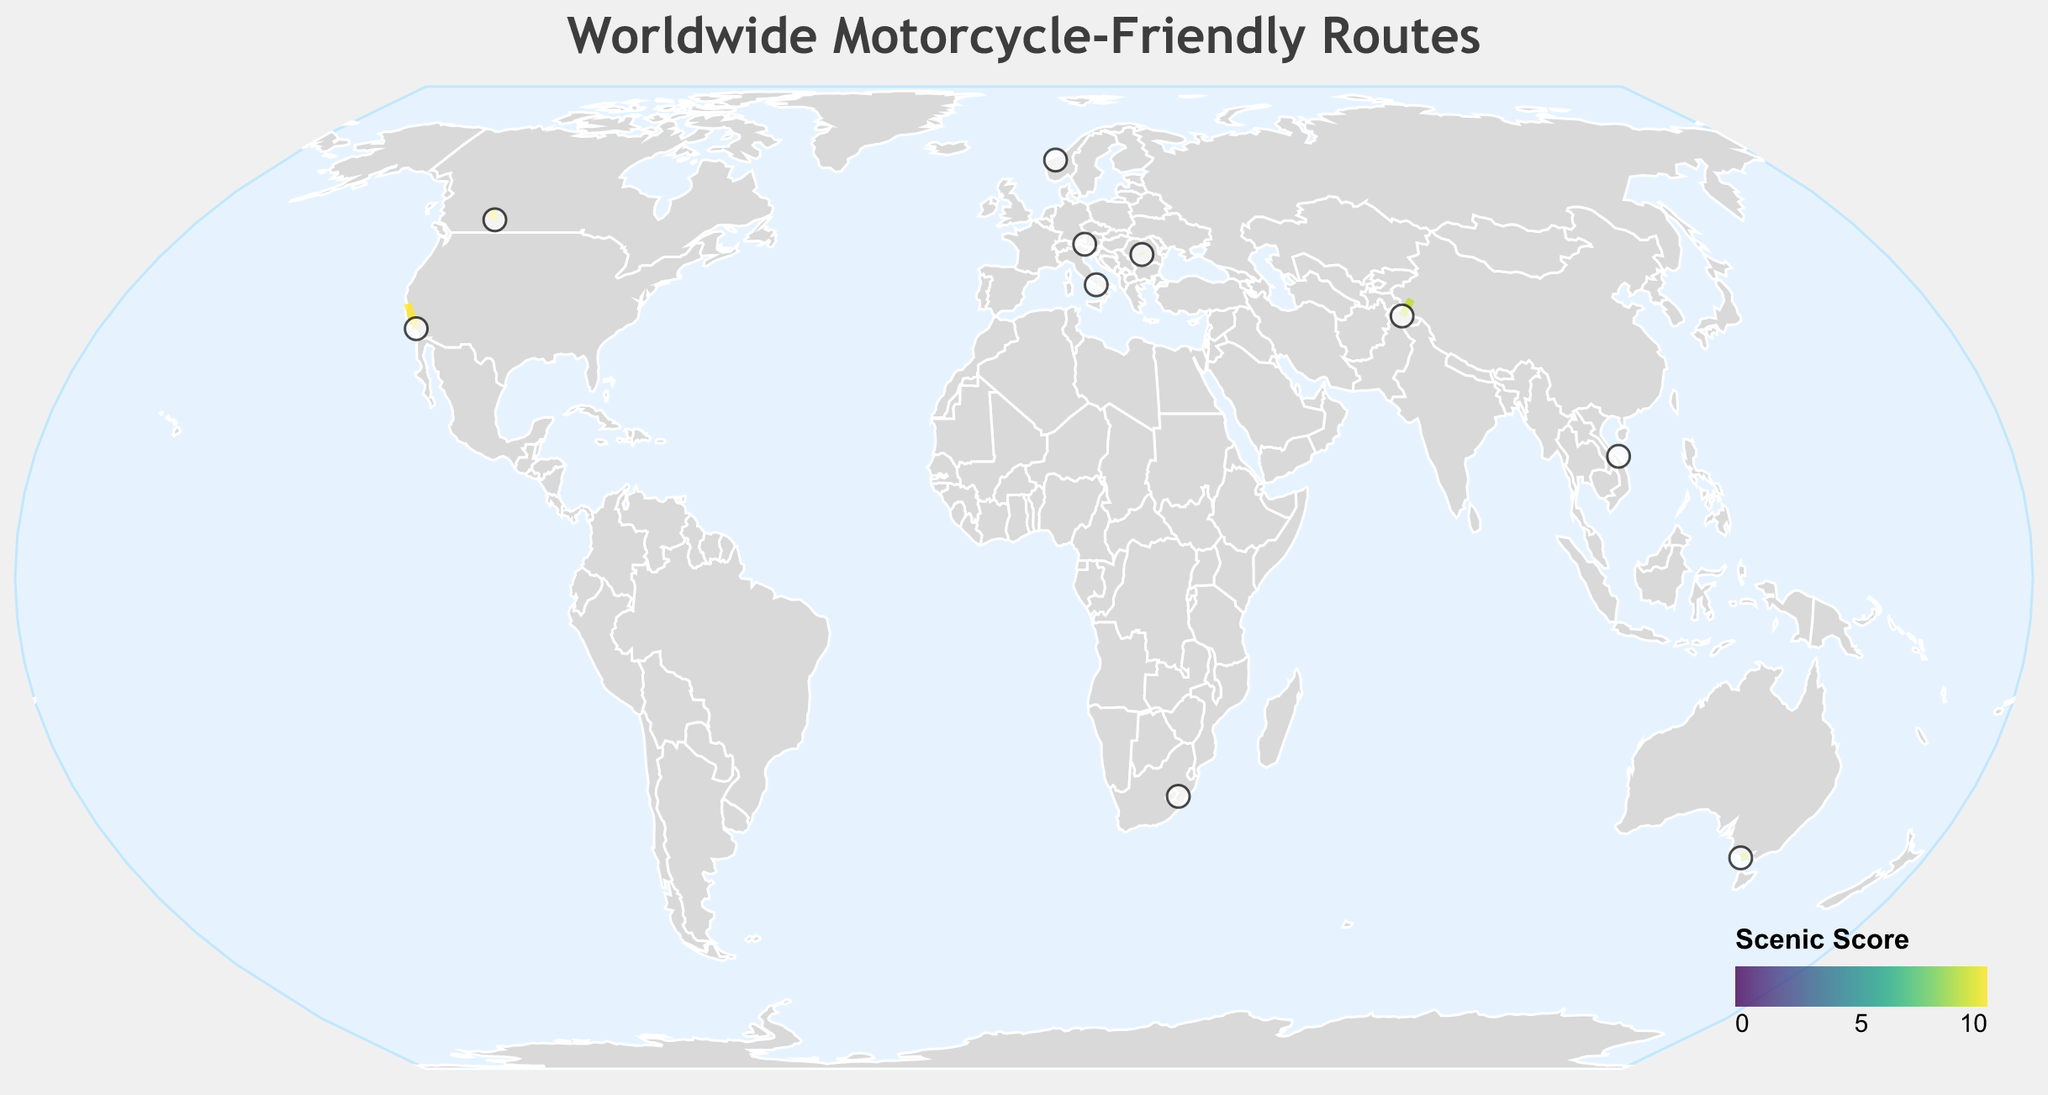What's the title of the figure? The title is usually located at the top of the figure.
Answer: Worldwide Motorcycle-Friendly Routes How many routes have the highest scenic score of 10? By checking the colors that correspond to a scenic score of 10 and matching those routes, we find three routes: Pacific Coast Highway, Trollstigen, Icefields Parkway, and Grossglockner High Alpine Road.
Answer: 4 Which route has the highest difficulty but a scenic score of less than 10? Check for the highest difficulty value that is less than 10 and look for its corresponding scenic score. The Sani Pass in Lesotho has a difficulty of 9 and a scenic score of 8.
Answer: Sani Pass Which continent has the most routes listed? By visually identifying the continents and counting the number of routes, it appears that Europe has the most routes listed (Romania, Norway, Italy, Austria).
Answer: Europe What's the average difficulty rating of all routes? Add up all difficulty ratings and divide by the number of routes: (7 + 4 + 3 + 8 + 6 + 5 + 7 + 9 + 8 + 6) / 10 = 63 / 10 = 6.3
Answer: 6.3 Which country has a route with the highest scenic score? Locate the country associated with any route that has a scenic score of 10. The routes are the Pacific Coast Highway (USA), Trollstigen (Norway), Icefields Parkway (Canada), and Grossglockner High Alpine Road (Austria).
Answer: USA, Norway, Canada, Austria Compare the difficulty levels of Trollstigen in Norway and the Great Ocean Road in Australia. Which is harder? Trollstigen has a difficulty level of 8, while the Great Ocean Road has a difficulty level of 3.
Answer: Trollstigen Are there any routes with the same start and end coordinates? By examining the coordinates, it appears there are no routes with identical start and end coordinates.
Answer: No Which route has the smallest geographic span between its start and end points? Compare the start and end coordinates of each route, calculating the distances visually or by checking for the smallest gap. The Trollstigen in Norway has very close start and end coordinates (62.4478, 7.6672) to (62.4546, 7.6697).
Answer: Trollstigen What's the median scenic score across all routes? List all scenic scores in order: 8, 8, 9, 9, 9, 9, 9, 10, 10, 10. The median of this ordered list (10 routes) would be the average of the middle two values (both 9).
Answer: 9 